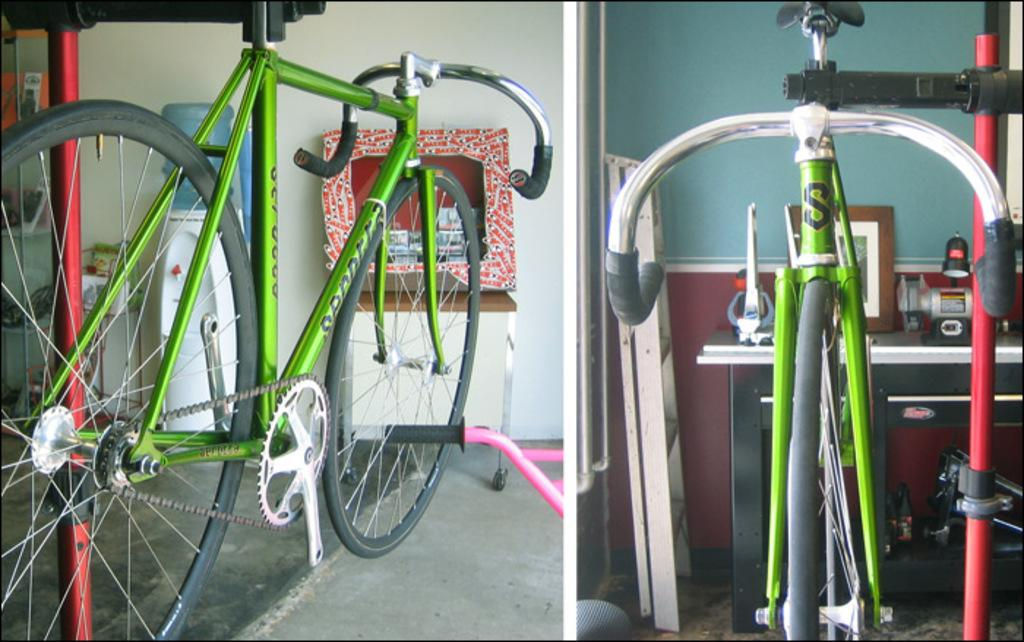What type of vehicle is in the image? There is a green cycle in the image. Has the image been altered in any way? Yes, the image has been edited. What is at the bottom of the image? There is a floor at the bottom of the image. What can be seen in the background of the image? There is a water filter and a table in the background of the image. What is the relation between the green cycle and the water filter in the image? There is no direct relation between the green cycle and the water filter in the image; they are simply two separate objects in the background. How does the green cycle contribute to the health of the person in the image? The image does not show a person, and the green cycle's impact on health cannot be determined from the image alone. 